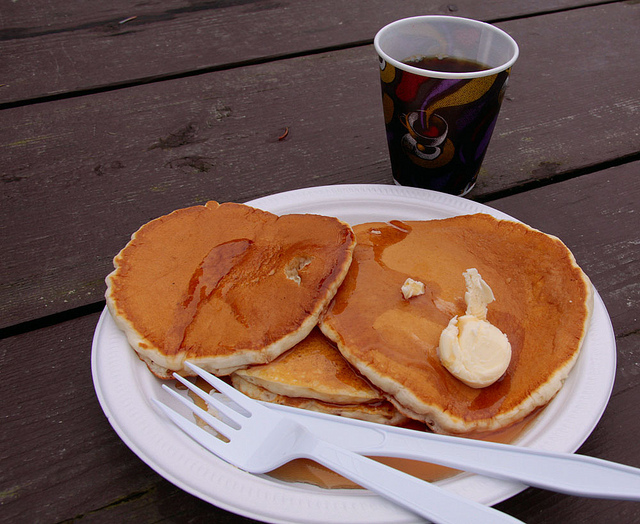<image>What fruit is on the pancake? I am unsure what fruit is on the pancake. It could be a banana, an apple, or none. What fruit is on the pancake? I am not sure what fruit is on the pancake. It can be seen banana or apple. 